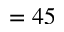Convert formula to latex. <formula><loc_0><loc_0><loc_500><loc_500>= 4 5</formula> 